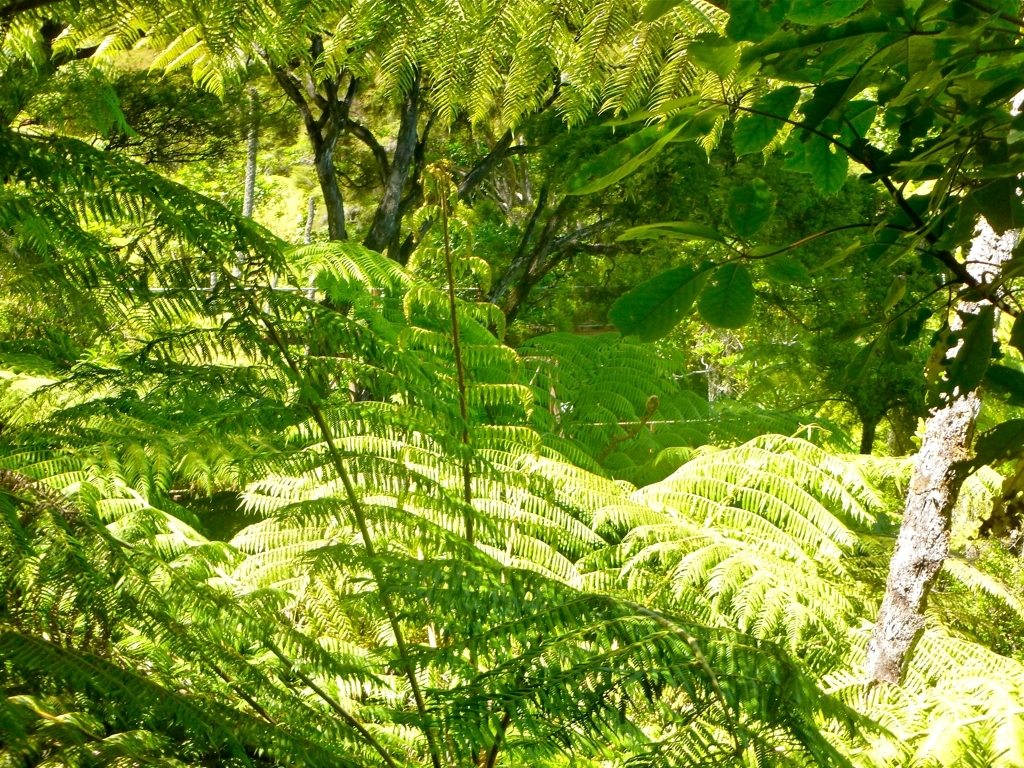How would you rate the quality of this picture? I'd classify the quality of this picture as relatively high—a 'B.' The picture is clear, with vivid colors and good contrast. The details in the foliage are crisp, and the lighting is well-balanced, allowing for an appreciation of the lush greenery of the scene. However, some areas might be slightly overexposed due to the brightness of the sunlight, which just stops it from being perfect. 